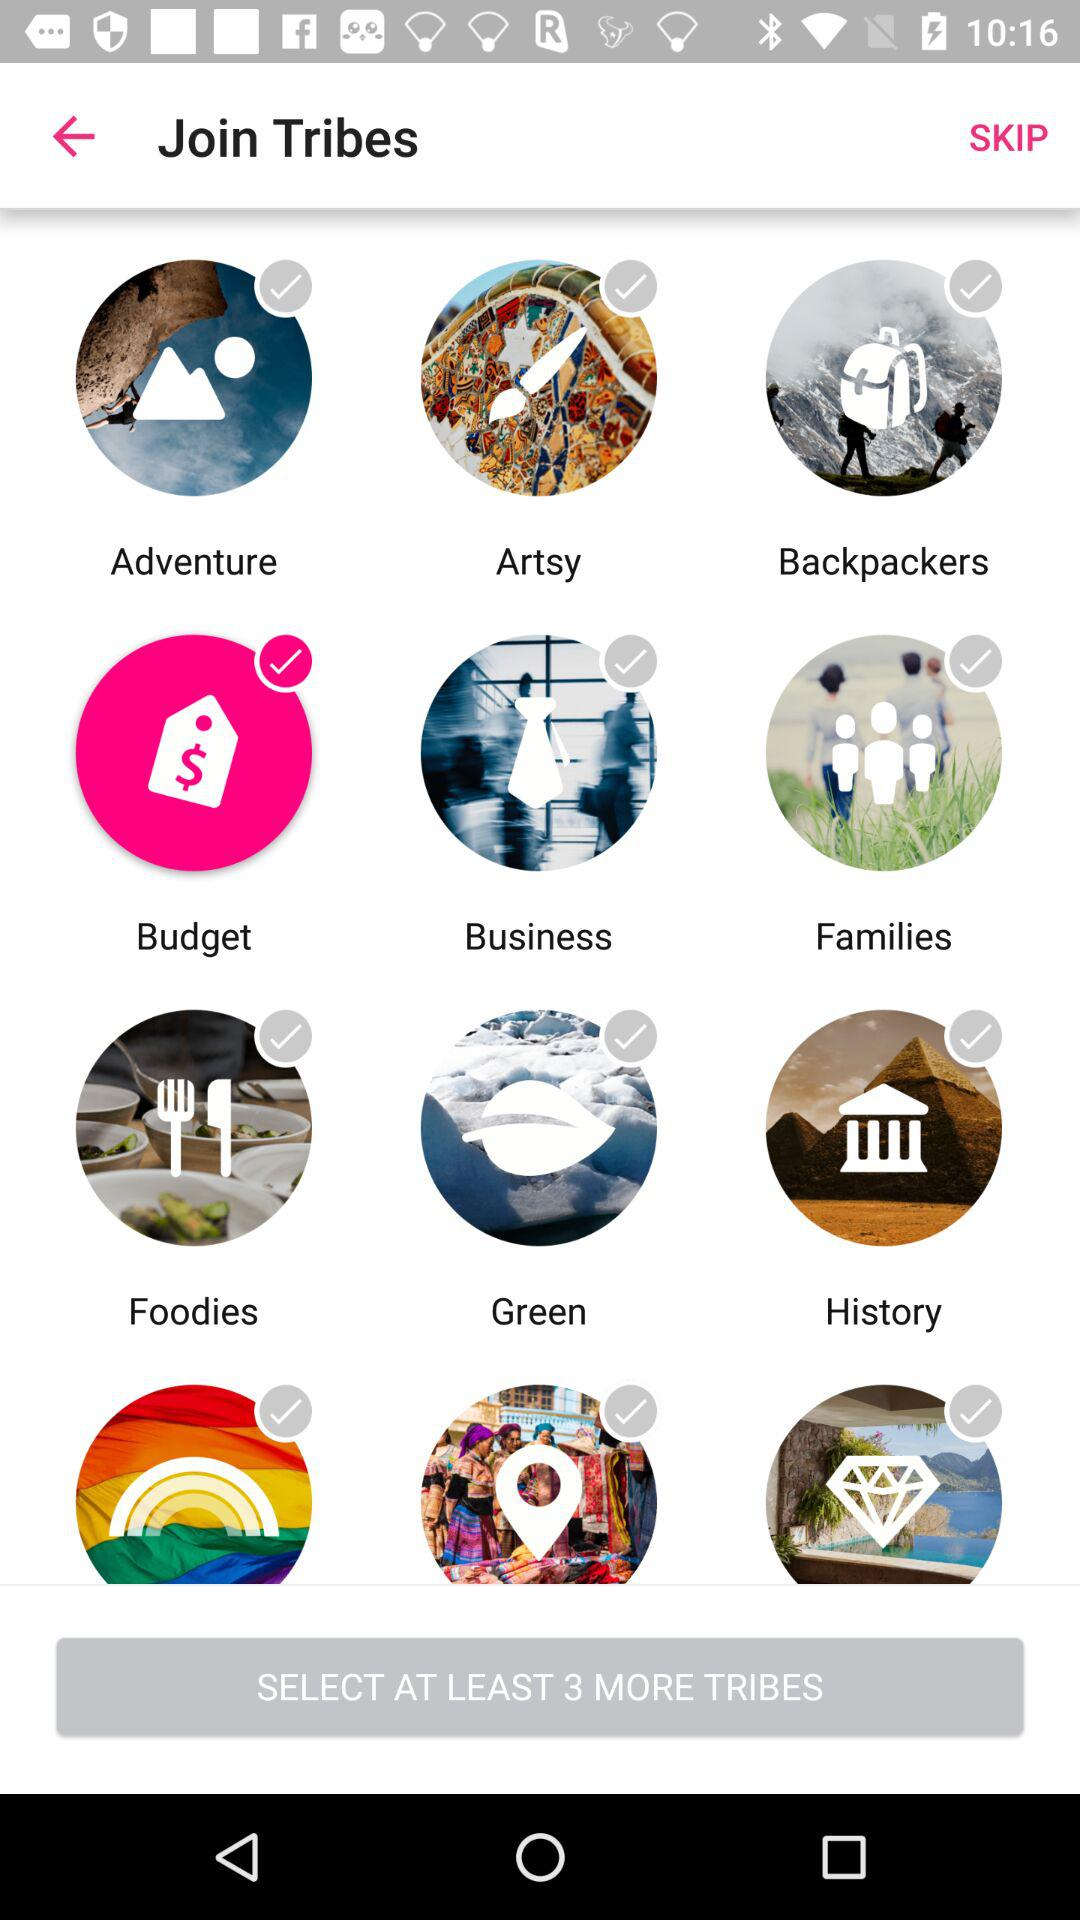Which option is selected? The selected option is "Budget". 